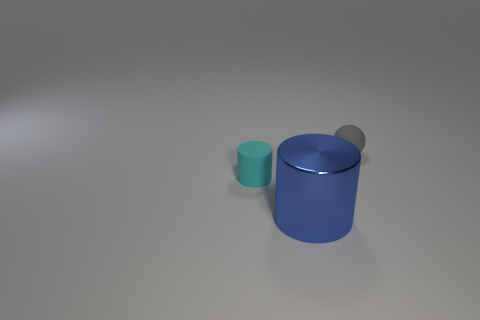What is the size of the rubber object left of the big object?
Offer a terse response. Small. There is a matte object that is on the left side of the blue cylinder; is there a small cyan thing that is left of it?
Offer a very short reply. No. Does the cylinder behind the big shiny cylinder have the same material as the gray ball?
Your response must be concise. Yes. What number of small objects are both to the right of the tiny cyan thing and in front of the small ball?
Offer a very short reply. 0. How many tiny gray balls are the same material as the gray object?
Give a very brief answer. 0. What color is the object that is the same material as the cyan cylinder?
Keep it short and to the point. Gray. Are there fewer blue shiny things than gray metallic balls?
Your answer should be very brief. No. What material is the object that is in front of the matte thing that is in front of the matte object that is behind the cyan rubber cylinder?
Provide a succinct answer. Metal. What is the material of the small cylinder?
Provide a short and direct response. Rubber. Do the tiny object that is to the left of the tiny sphere and the thing that is in front of the tiny cyan rubber cylinder have the same color?
Provide a succinct answer. No. 